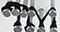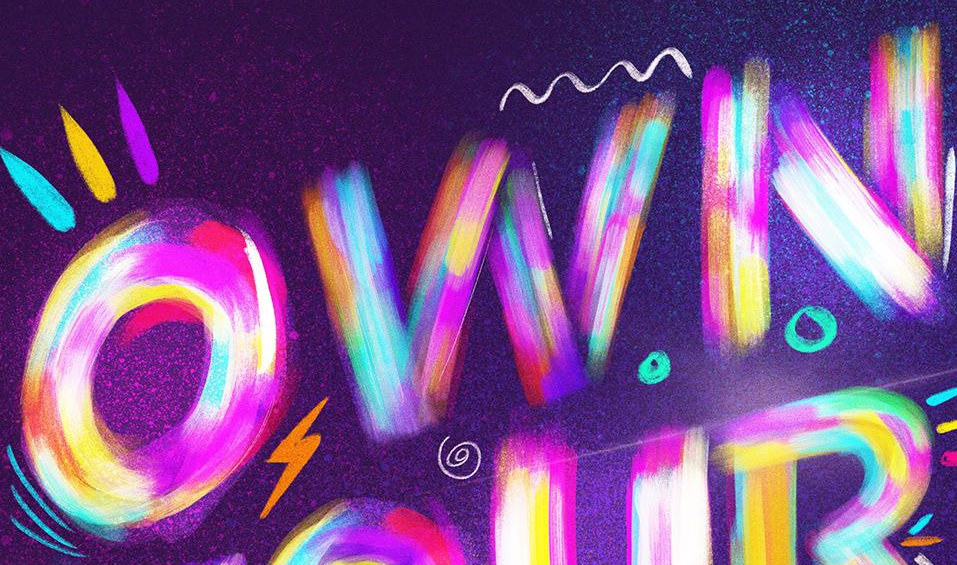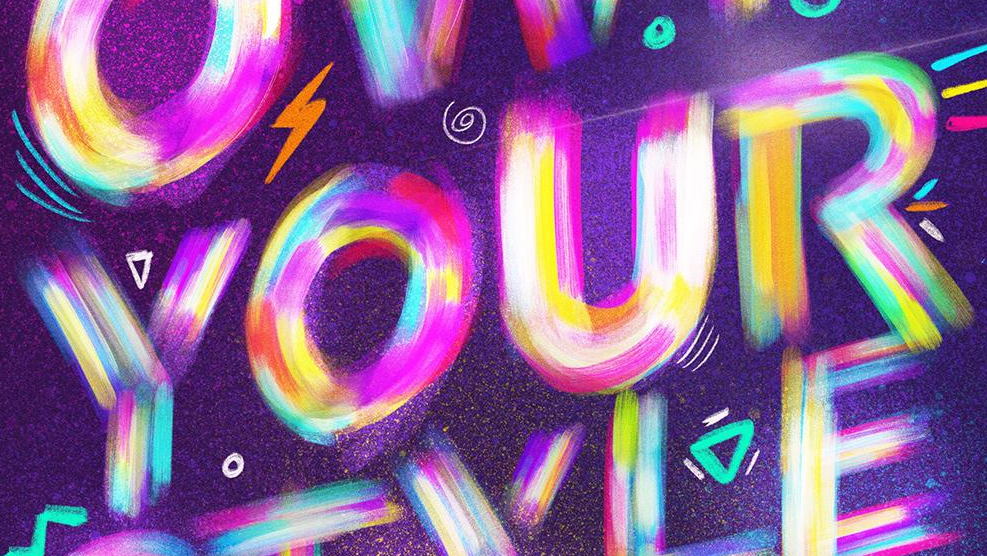What text appears in these images from left to right, separated by a semicolon? TM; OWN; YOUR 